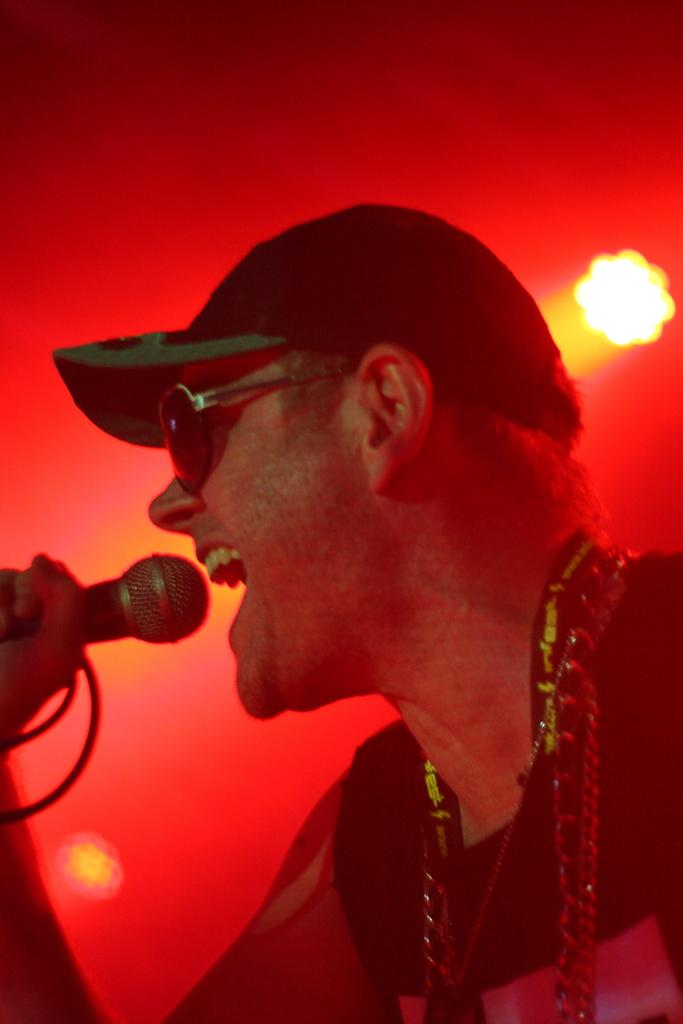What is the main subject of the image? There is a person in the image. What accessories is the person wearing? The person is wearing a cap and goggles. What object is the person holding? The person is holding a microphone. What can be seen in the background of the image? There are lights in the background of the image. What type of liquid is being poured from the microphone in the image? There is no liquid being poured from the microphone in the image; the person is simply holding a microphone. 